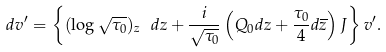Convert formula to latex. <formula><loc_0><loc_0><loc_500><loc_500>d v ^ { \prime } = \left \{ ( \log \sqrt { \tau _ { 0 } } ) _ { z } \ d z + \frac { i } { \sqrt { \tau _ { 0 } } } \left ( Q _ { 0 } d z + \frac { \tau _ { 0 } } { 4 } d \overline { z } \right ) J \right \} v ^ { \prime } .</formula> 